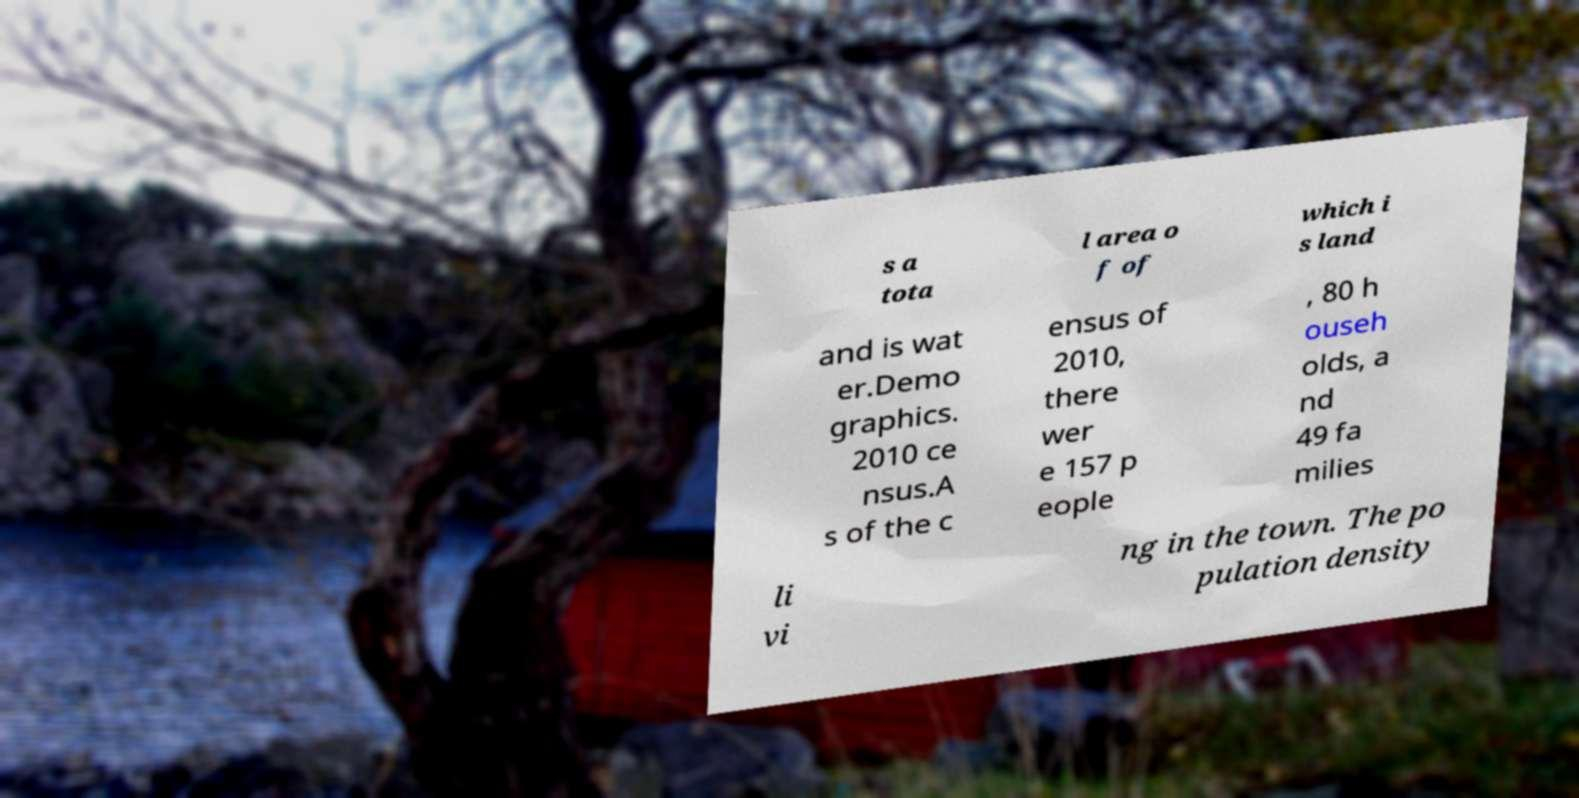I need the written content from this picture converted into text. Can you do that? s a tota l area o f of which i s land and is wat er.Demo graphics. 2010 ce nsus.A s of the c ensus of 2010, there wer e 157 p eople , 80 h ouseh olds, a nd 49 fa milies li vi ng in the town. The po pulation density 